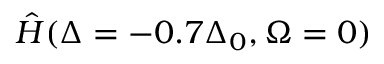Convert formula to latex. <formula><loc_0><loc_0><loc_500><loc_500>\hat { H } ( \Delta = - 0 . 7 \Delta _ { 0 } , \Omega = 0 )</formula> 